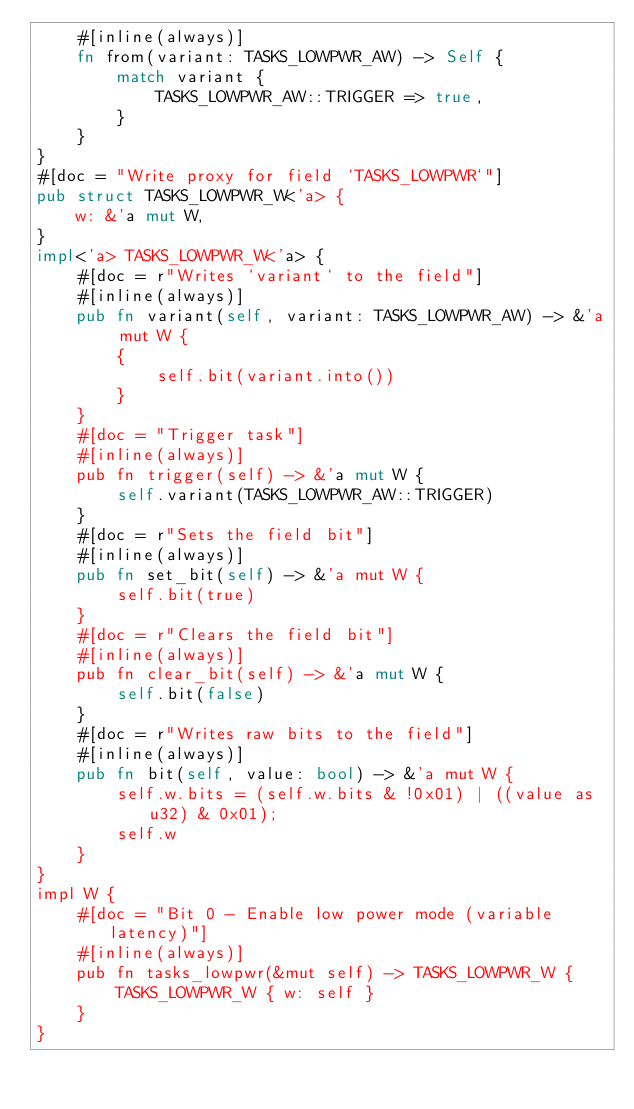<code> <loc_0><loc_0><loc_500><loc_500><_Rust_>    #[inline(always)]
    fn from(variant: TASKS_LOWPWR_AW) -> Self {
        match variant {
            TASKS_LOWPWR_AW::TRIGGER => true,
        }
    }
}
#[doc = "Write proxy for field `TASKS_LOWPWR`"]
pub struct TASKS_LOWPWR_W<'a> {
    w: &'a mut W,
}
impl<'a> TASKS_LOWPWR_W<'a> {
    #[doc = r"Writes `variant` to the field"]
    #[inline(always)]
    pub fn variant(self, variant: TASKS_LOWPWR_AW) -> &'a mut W {
        {
            self.bit(variant.into())
        }
    }
    #[doc = "Trigger task"]
    #[inline(always)]
    pub fn trigger(self) -> &'a mut W {
        self.variant(TASKS_LOWPWR_AW::TRIGGER)
    }
    #[doc = r"Sets the field bit"]
    #[inline(always)]
    pub fn set_bit(self) -> &'a mut W {
        self.bit(true)
    }
    #[doc = r"Clears the field bit"]
    #[inline(always)]
    pub fn clear_bit(self) -> &'a mut W {
        self.bit(false)
    }
    #[doc = r"Writes raw bits to the field"]
    #[inline(always)]
    pub fn bit(self, value: bool) -> &'a mut W {
        self.w.bits = (self.w.bits & !0x01) | ((value as u32) & 0x01);
        self.w
    }
}
impl W {
    #[doc = "Bit 0 - Enable low power mode (variable latency)"]
    #[inline(always)]
    pub fn tasks_lowpwr(&mut self) -> TASKS_LOWPWR_W {
        TASKS_LOWPWR_W { w: self }
    }
}
</code> 